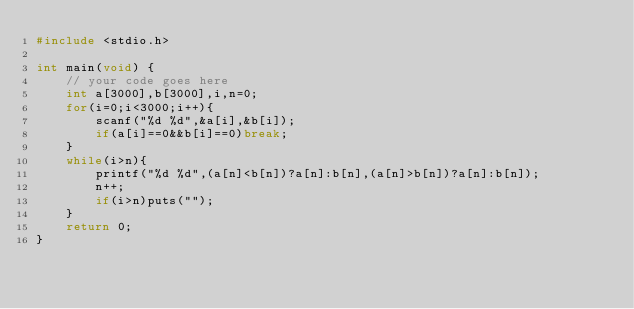Convert code to text. <code><loc_0><loc_0><loc_500><loc_500><_C_>#include <stdio.h>

int main(void) {
	// your code goes here
	int a[3000],b[3000],i,n=0;
	for(i=0;i<3000;i++){
		scanf("%d %d",&a[i],&b[i]);
		if(a[i]==0&&b[i]==0)break;
	}
	while(i>n){
		printf("%d %d",(a[n]<b[n])?a[n]:b[n],(a[n]>b[n])?a[n]:b[n]);
		n++;
		if(i>n)puts("");
	}
	return 0;
}

</code> 